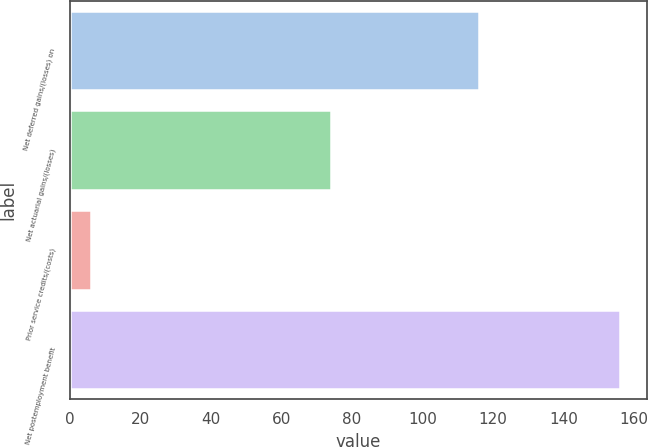Convert chart to OTSL. <chart><loc_0><loc_0><loc_500><loc_500><bar_chart><fcel>Net deferred gains/(losses) on<fcel>Net actuarial gains/(losses)<fcel>Prior service credits/(costs)<fcel>Net postemployment benefit<nl><fcel>116<fcel>74<fcel>6<fcel>156<nl></chart> 